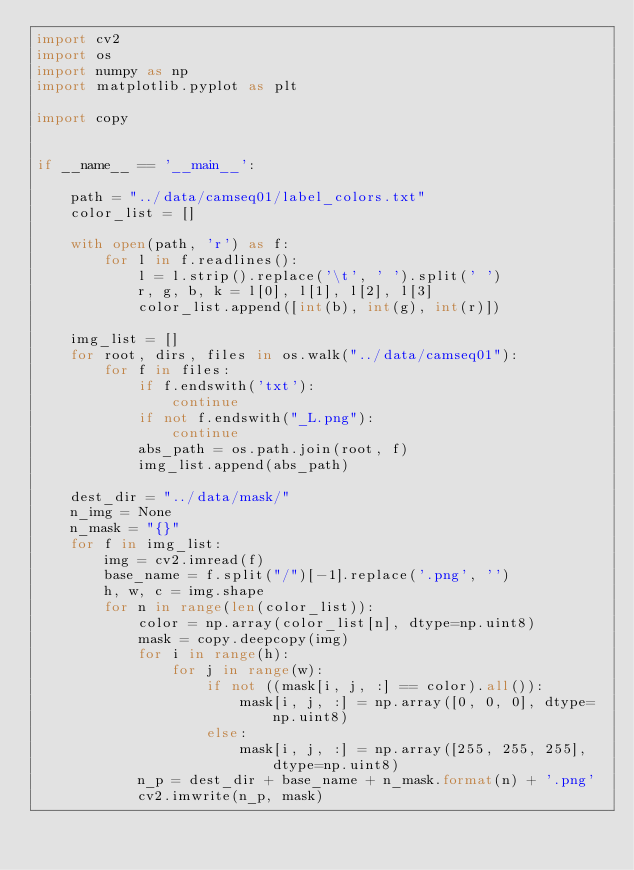<code> <loc_0><loc_0><loc_500><loc_500><_Python_>import cv2
import os
import numpy as np
import matplotlib.pyplot as plt

import copy


if __name__ == '__main__':

    path = "../data/camseq01/label_colors.txt"
    color_list = []

    with open(path, 'r') as f:
        for l in f.readlines():
            l = l.strip().replace('\t', ' ').split(' ')
            r, g, b, k = l[0], l[1], l[2], l[3]
            color_list.append([int(b), int(g), int(r)])

    img_list = []
    for root, dirs, files in os.walk("../data/camseq01"):
        for f in files:
            if f.endswith('txt'):
                continue
            if not f.endswith("_L.png"):
                continue
            abs_path = os.path.join(root, f)
            img_list.append(abs_path)

    dest_dir = "../data/mask/"
    n_img = None
    n_mask = "{}"
    for f in img_list:
        img = cv2.imread(f)
        base_name = f.split("/")[-1].replace('.png', '')
        h, w, c = img.shape
        for n in range(len(color_list)):
            color = np.array(color_list[n], dtype=np.uint8)
            mask = copy.deepcopy(img)
            for i in range(h):
                for j in range(w):
                    if not ((mask[i, j, :] == color).all()):
                        mask[i, j, :] = np.array([0, 0, 0], dtype=np.uint8)
                    else:
                        mask[i, j, :] = np.array([255, 255, 255], dtype=np.uint8)
            n_p = dest_dir + base_name + n_mask.format(n) + '.png'
            cv2.imwrite(n_p, mask)




</code> 